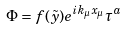<formula> <loc_0><loc_0><loc_500><loc_500>\Phi = f ( \tilde { y } ) e ^ { i k _ { \mu } x _ { \mu } } \tau ^ { a }</formula> 